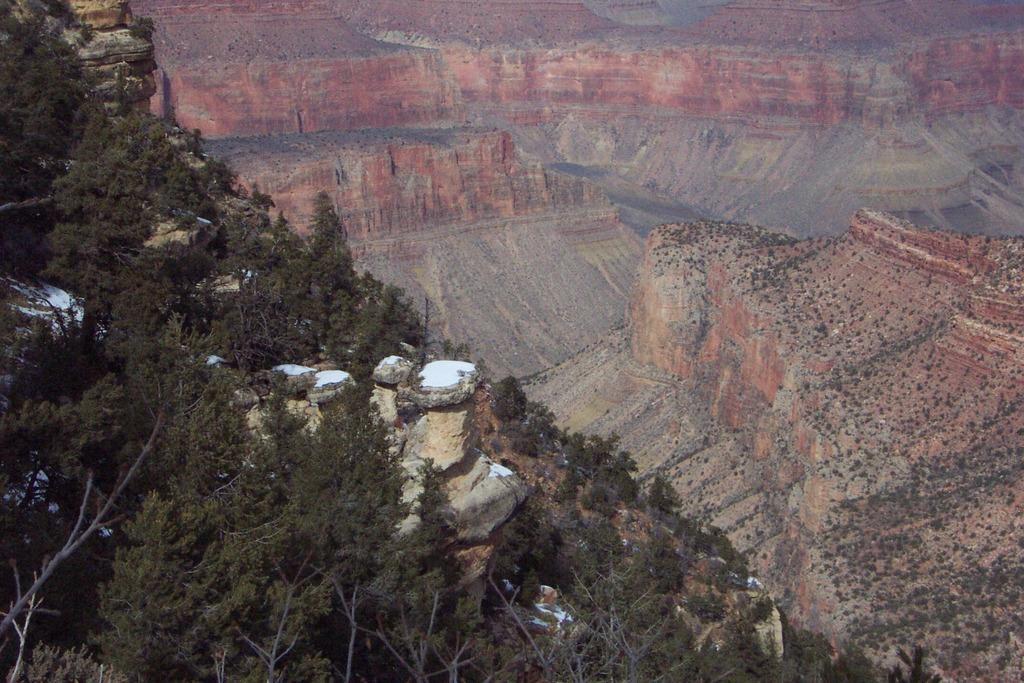Can you describe this image briefly? In this image I can see number of trees. 